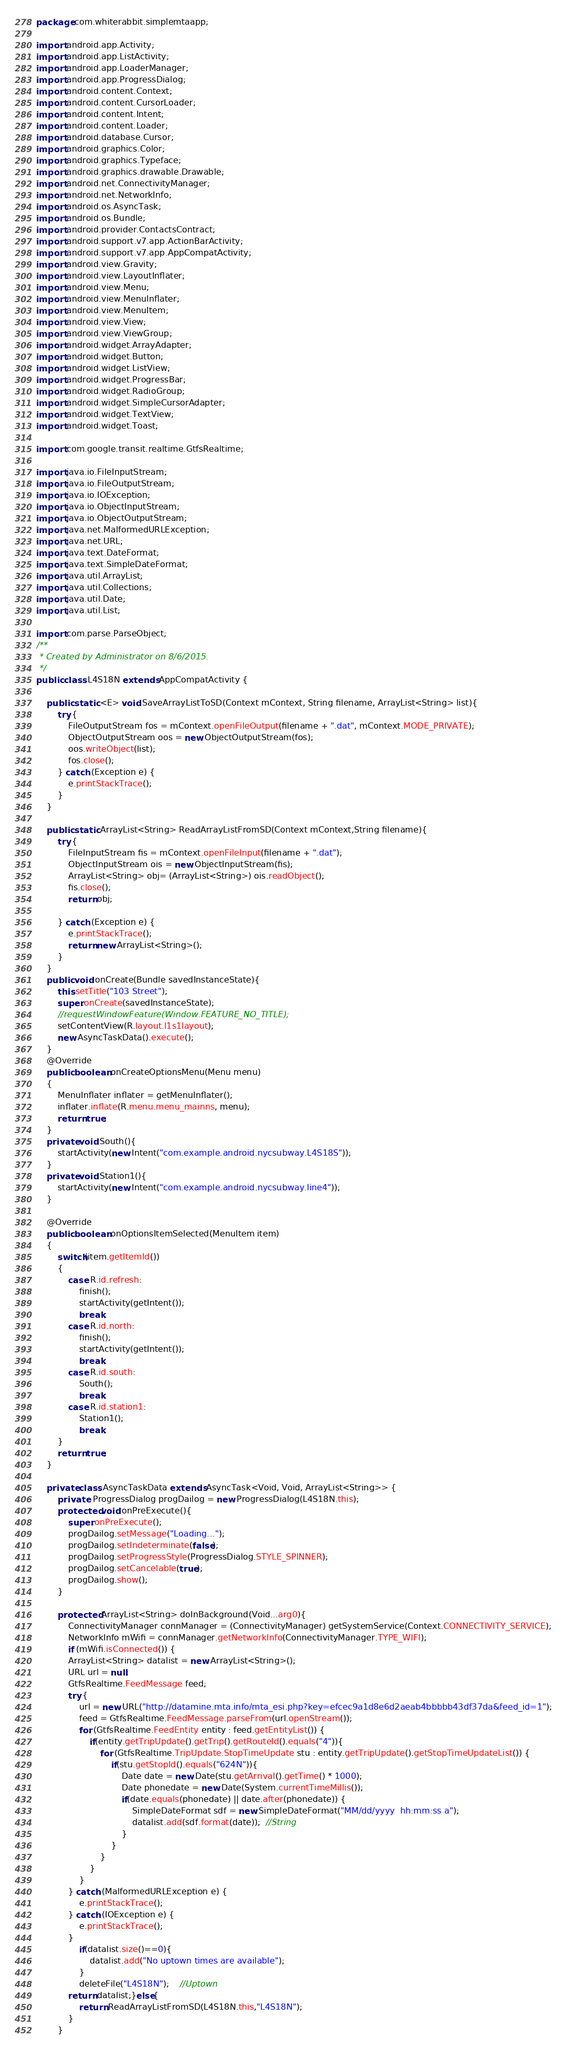Convert code to text. <code><loc_0><loc_0><loc_500><loc_500><_Java_>package com.whiterabbit.simplemtaapp;

import android.app.Activity;
import android.app.ListActivity;
import android.app.LoaderManager;
import android.app.ProgressDialog;
import android.content.Context;
import android.content.CursorLoader;
import android.content.Intent;
import android.content.Loader;
import android.database.Cursor;
import android.graphics.Color;
import android.graphics.Typeface;
import android.graphics.drawable.Drawable;
import android.net.ConnectivityManager;
import android.net.NetworkInfo;
import android.os.AsyncTask;
import android.os.Bundle;
import android.provider.ContactsContract;
import android.support.v7.app.ActionBarActivity;
import android.support.v7.app.AppCompatActivity;
import android.view.Gravity;
import android.view.LayoutInflater;
import android.view.Menu;
import android.view.MenuInflater;
import android.view.MenuItem;
import android.view.View;
import android.view.ViewGroup;
import android.widget.ArrayAdapter;
import android.widget.Button;
import android.widget.ListView;
import android.widget.ProgressBar;
import android.widget.RadioGroup;
import android.widget.SimpleCursorAdapter;
import android.widget.TextView;
import android.widget.Toast;

import com.google.transit.realtime.GtfsRealtime;

import java.io.FileInputStream;
import java.io.FileOutputStream;
import java.io.IOException;
import java.io.ObjectInputStream;
import java.io.ObjectOutputStream;
import java.net.MalformedURLException;
import java.net.URL;
import java.text.DateFormat;
import java.text.SimpleDateFormat;
import java.util.ArrayList;
import java.util.Collections;
import java.util.Date;
import java.util.List;

import com.parse.ParseObject;
/**
 * Created by Administrator on 8/6/2015.
 */
public class L4S18N extends AppCompatActivity {

    public static <E> void SaveArrayListToSD(Context mContext, String filename, ArrayList<String> list){
        try {
            FileOutputStream fos = mContext.openFileOutput(filename + ".dat", mContext.MODE_PRIVATE);
            ObjectOutputStream oos = new ObjectOutputStream(fos);
            oos.writeObject(list);
            fos.close();
        } catch (Exception e) {
            e.printStackTrace();
        }
    }

    public static ArrayList<String> ReadArrayListFromSD(Context mContext,String filename){
        try {
            FileInputStream fis = mContext.openFileInput(filename + ".dat");
            ObjectInputStream ois = new ObjectInputStream(fis);
            ArrayList<String> obj= (ArrayList<String>) ois.readObject();
            fis.close();
            return obj;

        } catch (Exception e) {
            e.printStackTrace();
            return new ArrayList<String>();
        }
    }
    public void onCreate(Bundle savedInstanceState){
        this.setTitle("103 Street");
        super.onCreate(savedInstanceState);
        //requestWindowFeature(Window.FEATURE_NO_TITLE);
        setContentView(R.layout.l1s1layout);
        new AsyncTaskData().execute();
    }
    @Override
    public boolean onCreateOptionsMenu(Menu menu)
    {
        MenuInflater inflater = getMenuInflater();
        inflater.inflate(R.menu.menu_mainns, menu);
        return true;
    }
    private void South(){
        startActivity(new Intent("com.example.android.nycsubway.L4S18S"));
    }
    private void Station1(){
        startActivity(new Intent("com.example.android.nycsubway.line4"));
    }

    @Override
    public boolean onOptionsItemSelected(MenuItem item)
    {
        switch(item.getItemId())
        {
            case R.id.refresh:
                finish();
                startActivity(getIntent());
                break;
            case R.id.north:
                finish();
                startActivity(getIntent());
                break;
            case R.id.south:
                South();
                break;
            case R.id.station1:
                Station1();
                break;
        }
        return true;
    }

    private class AsyncTaskData extends AsyncTask<Void, Void, ArrayList<String>> {
        private  ProgressDialog progDailog = new ProgressDialog(L4S18N.this);
        protected void onPreExecute(){
            super.onPreExecute();
            progDailog.setMessage("Loading...");
            progDailog.setIndeterminate(false);
            progDailog.setProgressStyle(ProgressDialog.STYLE_SPINNER);
            progDailog.setCancelable(true);
            progDailog.show();
        }

        protected ArrayList<String> doInBackground(Void...arg0){
            ConnectivityManager connManager = (ConnectivityManager) getSystemService(Context.CONNECTIVITY_SERVICE);
            NetworkInfo mWifi = connManager.getNetworkInfo(ConnectivityManager.TYPE_WIFI);
            if (mWifi.isConnected()) {
            ArrayList<String> datalist = new ArrayList<String>();
            URL url = null;
            GtfsRealtime.FeedMessage feed;
            try {
                url = new URL("http://datamine.mta.info/mta_esi.php?key=efcec9a1d8e6d2aeab4bbbbb43df37da&feed_id=1");
                feed = GtfsRealtime.FeedMessage.parseFrom(url.openStream());
                for (GtfsRealtime.FeedEntity entity : feed.getEntityList()) {
                    if(entity.getTripUpdate().getTrip().getRouteId().equals("4")){
                        for (GtfsRealtime.TripUpdate.StopTimeUpdate stu : entity.getTripUpdate().getStopTimeUpdateList()) {
                            if(stu.getStopId().equals("624N")){
                                Date date = new Date(stu.getArrival().getTime() * 1000);
                                Date phonedate = new Date(System.currentTimeMillis());
                                if(date.equals(phonedate) || date.after(phonedate)) {
                                    SimpleDateFormat sdf = new SimpleDateFormat("MM/dd/yyyy  hh:mm:ss a");
                                    datalist.add(sdf.format(date));  //String
                                }
                            }
                        }
                    }
                }
            } catch (MalformedURLException e) {
                e.printStackTrace();
            } catch (IOException e) {
                e.printStackTrace();
            }
                if(datalist.size()==0){
                    datalist.add("No uptown times are available");
                }
                deleteFile("L4S18N");	//Uptown
            return datalist;}else{
                return ReadArrayListFromSD(L4S18N.this,"L4S18N");
            }
        }
</code> 